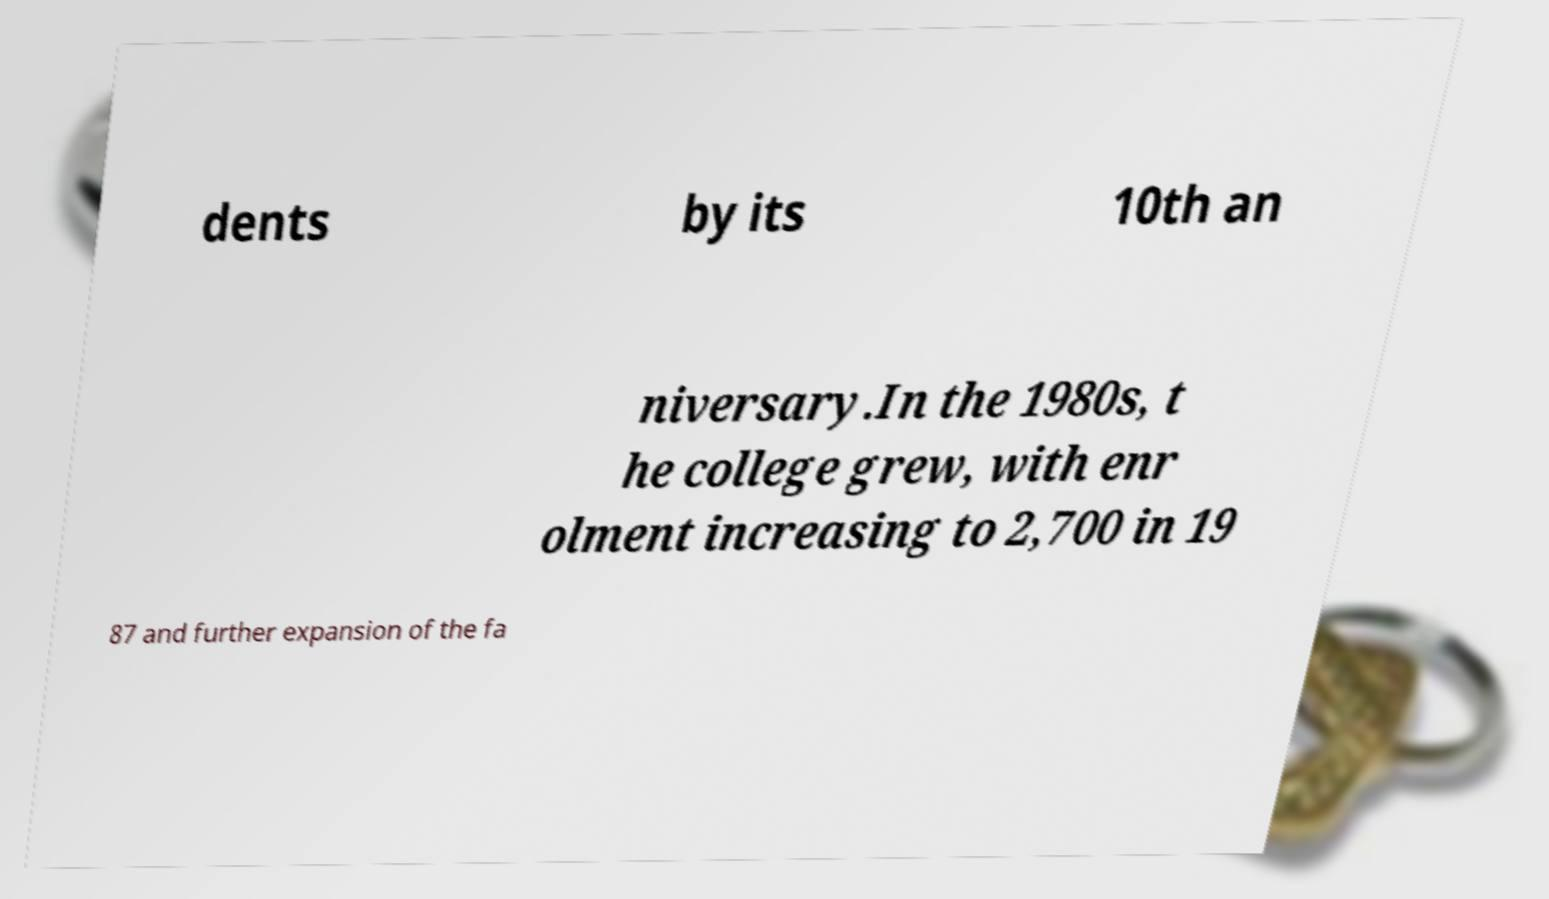There's text embedded in this image that I need extracted. Can you transcribe it verbatim? dents by its 10th an niversary.In the 1980s, t he college grew, with enr olment increasing to 2,700 in 19 87 and further expansion of the fa 